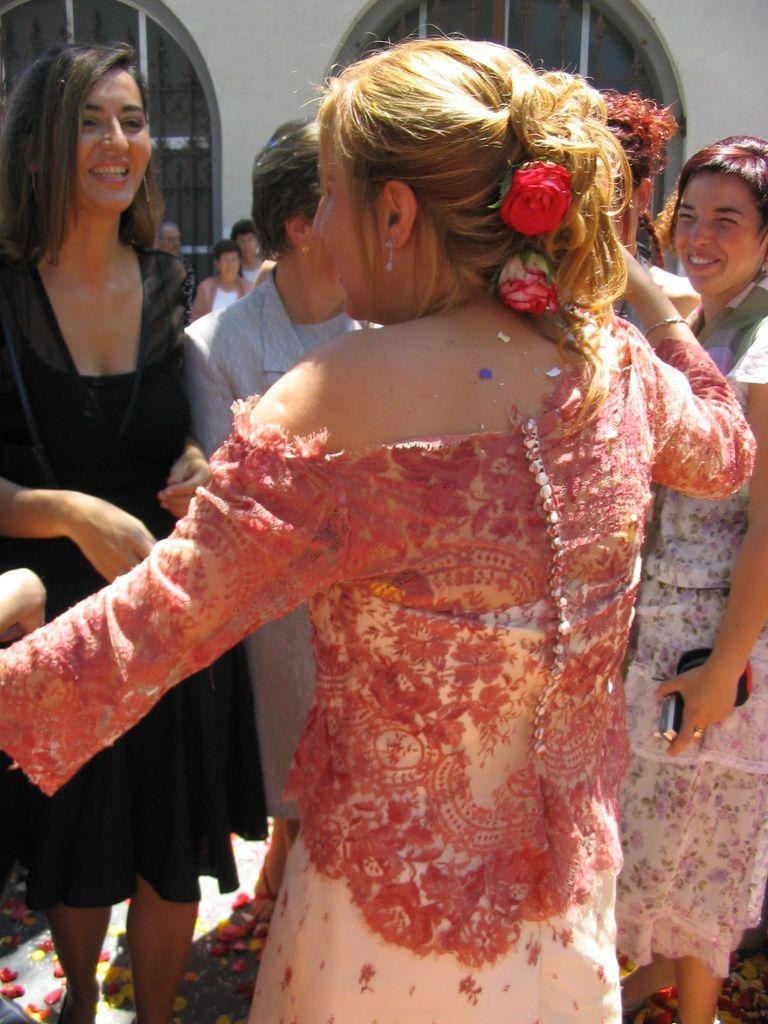What is the appearance of the woman in the image? The woman in the image has blond hair and is wearing a peach color dress. What is the woman doing in the image? The woman is dancing. What can be seen in the background of the image? There are many women standing and smiling in the background, and there is a building in the background as well. What type of underwear is the woman wearing in the image? There is no information about the woman's underwear in the image, so it cannot be determined. 